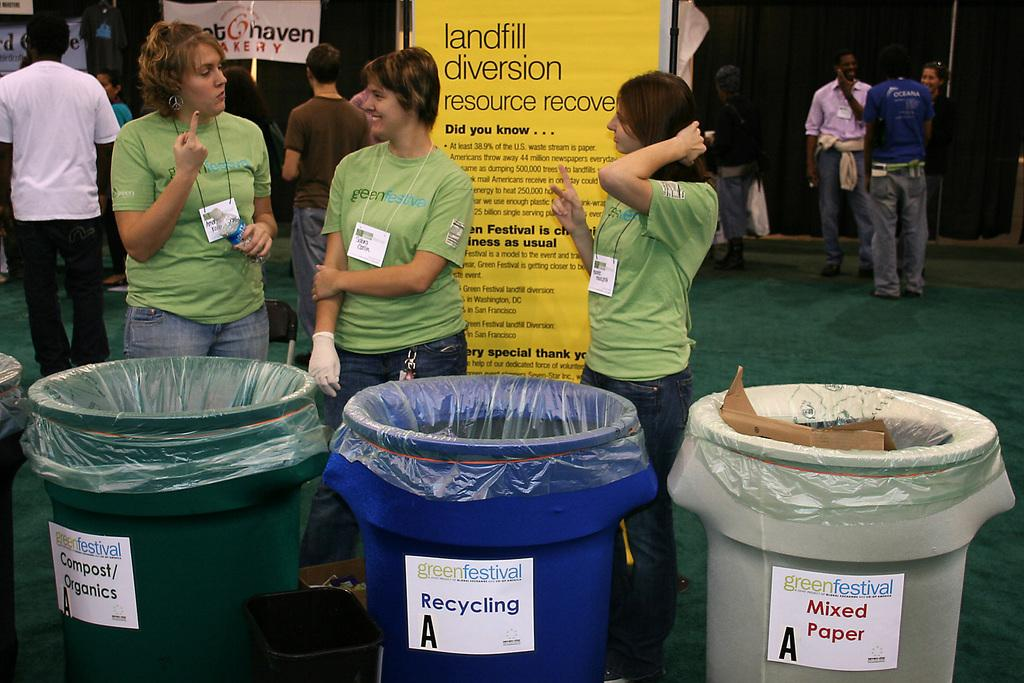<image>
Present a compact description of the photo's key features. Landfill Diversion resource recovery is a sign pictured about recycling. 